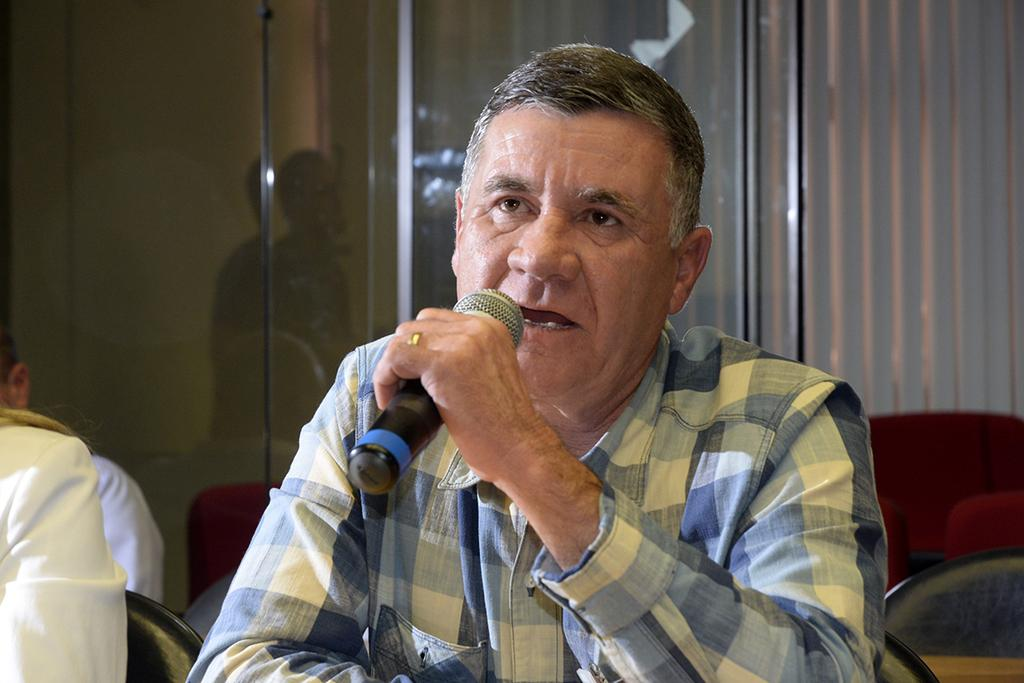What is the person in the image doing? The person is sitting in a chair and speaking in front of a mic. Are there any other people in the image? Yes, there are two other persons sitting beside the first person. What might be the purpose of the mic in the image? The mic might be used for amplifying the person's voice during a speech or presentation. What is the value of the heat generated by the respect in the image? There is no mention of heat or respect in the image, so it is not possible to determine the value of any heat generated by respect. 